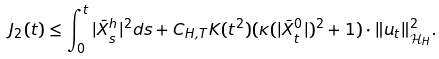Convert formula to latex. <formula><loc_0><loc_0><loc_500><loc_500>J _ { 2 } ( t ) & \leq \int _ { 0 } ^ { t } | \bar { X } _ { s } ^ { h } | ^ { 2 } d s + C _ { H , T } K ( t ^ { 2 } ) { ( \kappa ( | \bar { X } _ { t } ^ { 0 } | ) ^ { 2 } + 1 ) } \cdot \| u _ { t } \| ^ { 2 } _ { \mathcal { H } _ { H } } .</formula> 